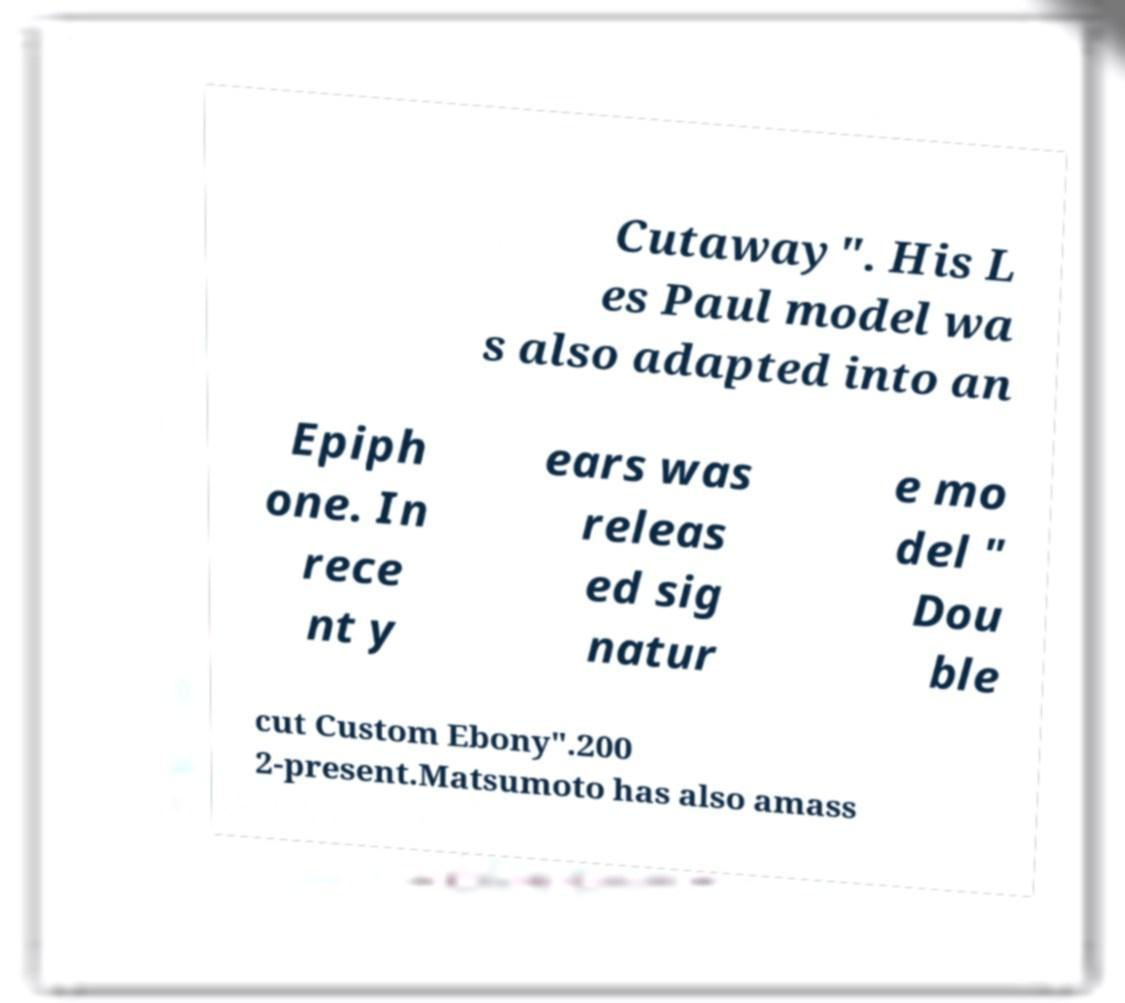There's text embedded in this image that I need extracted. Can you transcribe it verbatim? Cutaway". His L es Paul model wa s also adapted into an Epiph one. In rece nt y ears was releas ed sig natur e mo del " Dou ble cut Custom Ebony".200 2-present.Matsumoto has also amass 